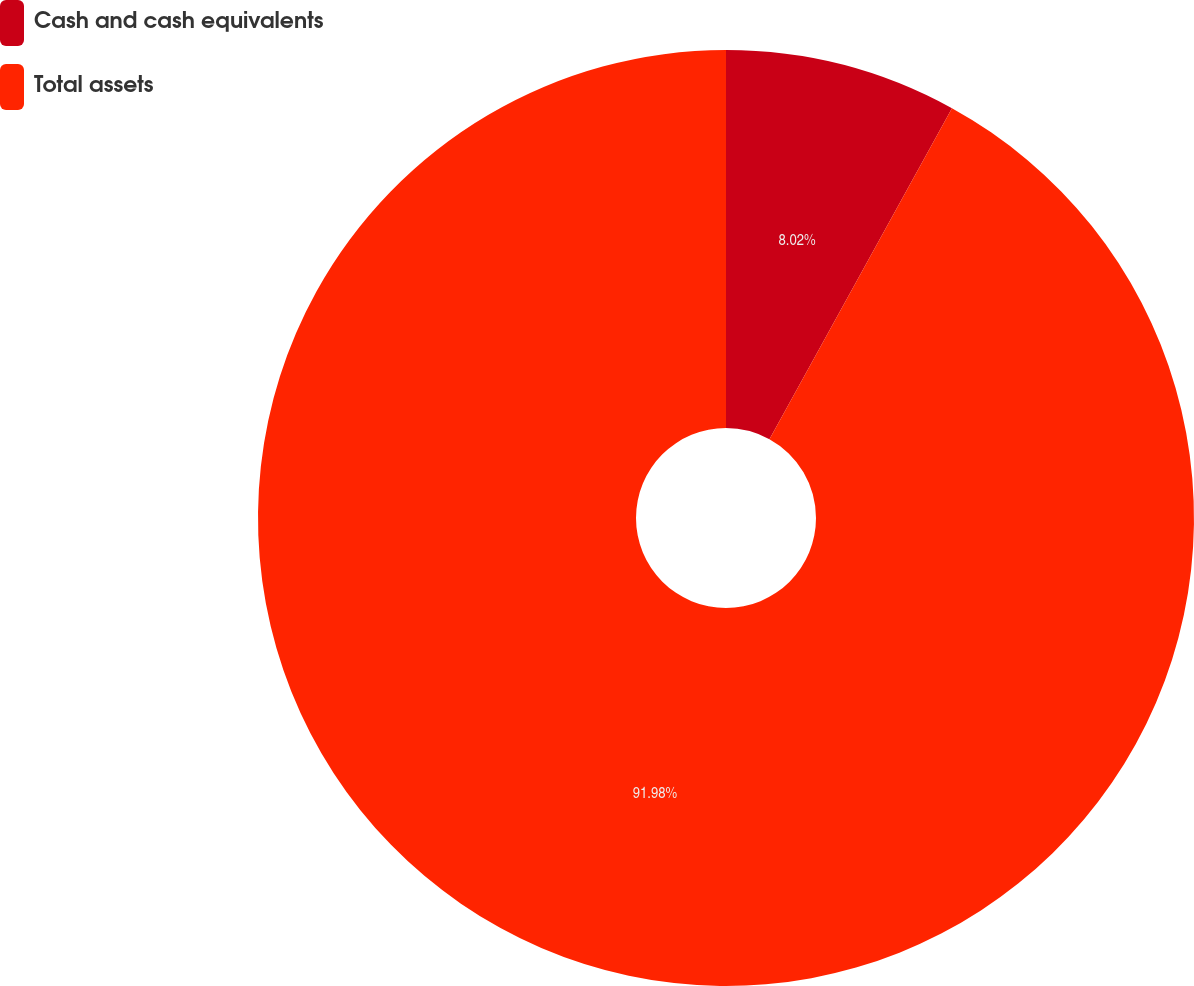Convert chart to OTSL. <chart><loc_0><loc_0><loc_500><loc_500><pie_chart><fcel>Cash and cash equivalents<fcel>Total assets<nl><fcel>8.02%<fcel>91.98%<nl></chart> 